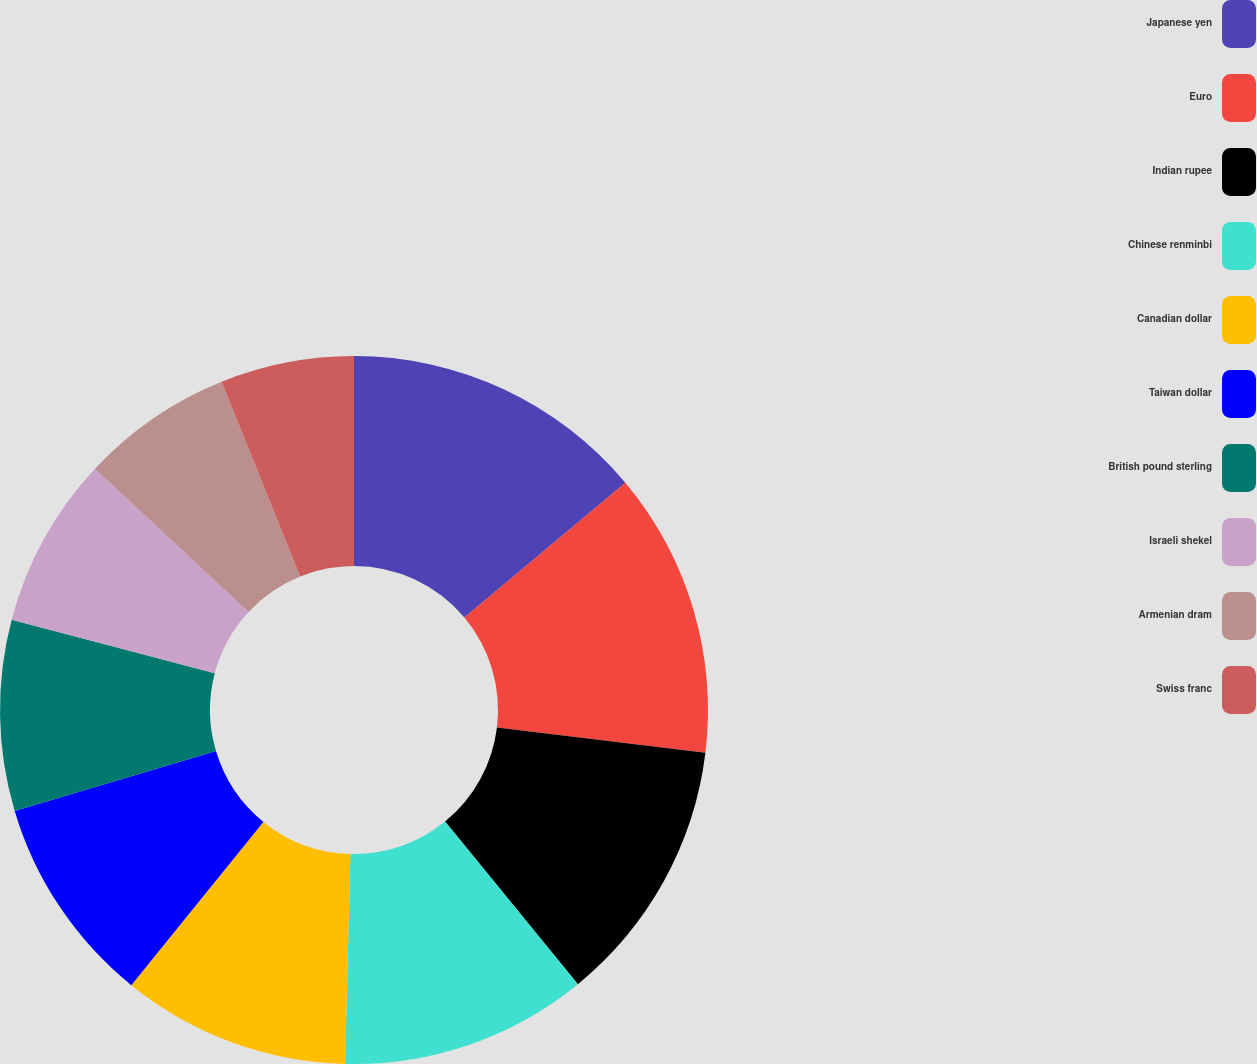Convert chart. <chart><loc_0><loc_0><loc_500><loc_500><pie_chart><fcel>Japanese yen<fcel>Euro<fcel>Indian rupee<fcel>Chinese renminbi<fcel>Canadian dollar<fcel>Taiwan dollar<fcel>British pound sterling<fcel>Israeli shekel<fcel>Armenian dram<fcel>Swiss franc<nl><fcel>13.9%<fcel>13.03%<fcel>12.17%<fcel>11.3%<fcel>10.43%<fcel>9.57%<fcel>8.7%<fcel>7.83%<fcel>6.97%<fcel>6.1%<nl></chart> 